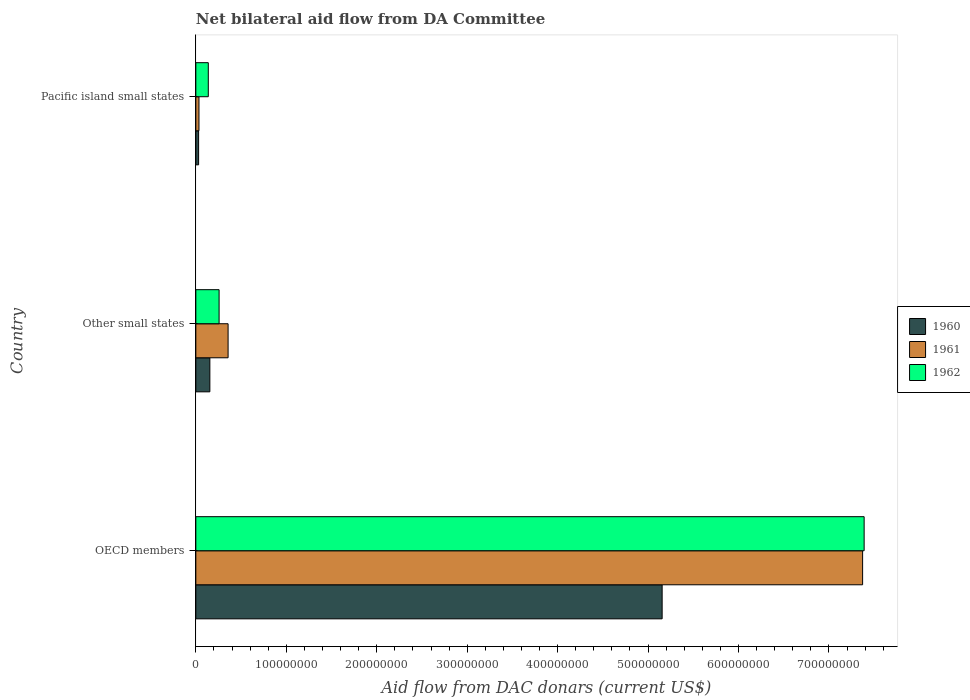How many groups of bars are there?
Make the answer very short. 3. Are the number of bars per tick equal to the number of legend labels?
Your answer should be very brief. Yes. Are the number of bars on each tick of the Y-axis equal?
Make the answer very short. Yes. What is the label of the 2nd group of bars from the top?
Your response must be concise. Other small states. In how many cases, is the number of bars for a given country not equal to the number of legend labels?
Your answer should be very brief. 0. What is the aid flow in in 1962 in OECD members?
Ensure brevity in your answer.  7.39e+08. Across all countries, what is the maximum aid flow in in 1962?
Give a very brief answer. 7.39e+08. Across all countries, what is the minimum aid flow in in 1962?
Your response must be concise. 1.38e+07. In which country was the aid flow in in 1960 maximum?
Provide a succinct answer. OECD members. In which country was the aid flow in in 1961 minimum?
Keep it short and to the point. Pacific island small states. What is the total aid flow in in 1961 in the graph?
Provide a succinct answer. 7.76e+08. What is the difference between the aid flow in in 1962 in OECD members and that in Other small states?
Keep it short and to the point. 7.13e+08. What is the difference between the aid flow in in 1960 in Pacific island small states and the aid flow in in 1962 in OECD members?
Give a very brief answer. -7.36e+08. What is the average aid flow in in 1961 per country?
Provide a short and direct response. 2.59e+08. What is the difference between the aid flow in in 1960 and aid flow in in 1961 in Pacific island small states?
Provide a succinct answer. -3.90e+05. What is the ratio of the aid flow in in 1962 in OECD members to that in Pacific island small states?
Offer a terse response. 53.62. Is the aid flow in in 1960 in OECD members less than that in Other small states?
Offer a very short reply. No. What is the difference between the highest and the second highest aid flow in in 1960?
Ensure brevity in your answer.  5.00e+08. What is the difference between the highest and the lowest aid flow in in 1962?
Offer a terse response. 7.25e+08. Is the sum of the aid flow in in 1960 in OECD members and Pacific island small states greater than the maximum aid flow in in 1961 across all countries?
Provide a succinct answer. No. What does the 3rd bar from the top in OECD members represents?
Your response must be concise. 1960. What does the 3rd bar from the bottom in Pacific island small states represents?
Offer a very short reply. 1962. Is it the case that in every country, the sum of the aid flow in in 1961 and aid flow in in 1960 is greater than the aid flow in in 1962?
Provide a short and direct response. No. How many countries are there in the graph?
Make the answer very short. 3. What is the difference between two consecutive major ticks on the X-axis?
Make the answer very short. 1.00e+08. Are the values on the major ticks of X-axis written in scientific E-notation?
Make the answer very short. No. Does the graph contain grids?
Give a very brief answer. No. Where does the legend appear in the graph?
Make the answer very short. Center right. How many legend labels are there?
Your response must be concise. 3. What is the title of the graph?
Offer a very short reply. Net bilateral aid flow from DA Committee. Does "1984" appear as one of the legend labels in the graph?
Offer a very short reply. No. What is the label or title of the X-axis?
Give a very brief answer. Aid flow from DAC donars (current US$). What is the Aid flow from DAC donars (current US$) in 1960 in OECD members?
Your answer should be very brief. 5.16e+08. What is the Aid flow from DAC donars (current US$) of 1961 in OECD members?
Offer a very short reply. 7.37e+08. What is the Aid flow from DAC donars (current US$) of 1962 in OECD members?
Make the answer very short. 7.39e+08. What is the Aid flow from DAC donars (current US$) of 1960 in Other small states?
Your answer should be very brief. 1.55e+07. What is the Aid flow from DAC donars (current US$) in 1961 in Other small states?
Make the answer very short. 3.57e+07. What is the Aid flow from DAC donars (current US$) in 1962 in Other small states?
Ensure brevity in your answer.  2.57e+07. What is the Aid flow from DAC donars (current US$) of 1960 in Pacific island small states?
Offer a very short reply. 3.08e+06. What is the Aid flow from DAC donars (current US$) in 1961 in Pacific island small states?
Provide a succinct answer. 3.47e+06. What is the Aid flow from DAC donars (current US$) in 1962 in Pacific island small states?
Give a very brief answer. 1.38e+07. Across all countries, what is the maximum Aid flow from DAC donars (current US$) of 1960?
Your answer should be compact. 5.16e+08. Across all countries, what is the maximum Aid flow from DAC donars (current US$) of 1961?
Offer a very short reply. 7.37e+08. Across all countries, what is the maximum Aid flow from DAC donars (current US$) in 1962?
Your answer should be very brief. 7.39e+08. Across all countries, what is the minimum Aid flow from DAC donars (current US$) in 1960?
Keep it short and to the point. 3.08e+06. Across all countries, what is the minimum Aid flow from DAC donars (current US$) of 1961?
Provide a succinct answer. 3.47e+06. Across all countries, what is the minimum Aid flow from DAC donars (current US$) of 1962?
Your answer should be compact. 1.38e+07. What is the total Aid flow from DAC donars (current US$) in 1960 in the graph?
Give a very brief answer. 5.34e+08. What is the total Aid flow from DAC donars (current US$) of 1961 in the graph?
Your answer should be very brief. 7.76e+08. What is the total Aid flow from DAC donars (current US$) in 1962 in the graph?
Keep it short and to the point. 7.78e+08. What is the difference between the Aid flow from DAC donars (current US$) of 1960 in OECD members and that in Other small states?
Your answer should be very brief. 5.00e+08. What is the difference between the Aid flow from DAC donars (current US$) of 1961 in OECD members and that in Other small states?
Provide a short and direct response. 7.02e+08. What is the difference between the Aid flow from DAC donars (current US$) in 1962 in OECD members and that in Other small states?
Your answer should be compact. 7.13e+08. What is the difference between the Aid flow from DAC donars (current US$) in 1960 in OECD members and that in Pacific island small states?
Your response must be concise. 5.12e+08. What is the difference between the Aid flow from DAC donars (current US$) in 1961 in OECD members and that in Pacific island small states?
Provide a succinct answer. 7.34e+08. What is the difference between the Aid flow from DAC donars (current US$) in 1962 in OECD members and that in Pacific island small states?
Your answer should be compact. 7.25e+08. What is the difference between the Aid flow from DAC donars (current US$) in 1960 in Other small states and that in Pacific island small states?
Ensure brevity in your answer.  1.24e+07. What is the difference between the Aid flow from DAC donars (current US$) in 1961 in Other small states and that in Pacific island small states?
Ensure brevity in your answer.  3.22e+07. What is the difference between the Aid flow from DAC donars (current US$) in 1962 in Other small states and that in Pacific island small states?
Keep it short and to the point. 1.19e+07. What is the difference between the Aid flow from DAC donars (current US$) in 1960 in OECD members and the Aid flow from DAC donars (current US$) in 1961 in Other small states?
Provide a succinct answer. 4.80e+08. What is the difference between the Aid flow from DAC donars (current US$) in 1960 in OECD members and the Aid flow from DAC donars (current US$) in 1962 in Other small states?
Your answer should be compact. 4.90e+08. What is the difference between the Aid flow from DAC donars (current US$) in 1961 in OECD members and the Aid flow from DAC donars (current US$) in 1962 in Other small states?
Offer a terse response. 7.11e+08. What is the difference between the Aid flow from DAC donars (current US$) in 1960 in OECD members and the Aid flow from DAC donars (current US$) in 1961 in Pacific island small states?
Provide a succinct answer. 5.12e+08. What is the difference between the Aid flow from DAC donars (current US$) in 1960 in OECD members and the Aid flow from DAC donars (current US$) in 1962 in Pacific island small states?
Offer a very short reply. 5.02e+08. What is the difference between the Aid flow from DAC donars (current US$) of 1961 in OECD members and the Aid flow from DAC donars (current US$) of 1962 in Pacific island small states?
Offer a very short reply. 7.23e+08. What is the difference between the Aid flow from DAC donars (current US$) in 1960 in Other small states and the Aid flow from DAC donars (current US$) in 1961 in Pacific island small states?
Make the answer very short. 1.20e+07. What is the difference between the Aid flow from DAC donars (current US$) of 1960 in Other small states and the Aid flow from DAC donars (current US$) of 1962 in Pacific island small states?
Your response must be concise. 1.74e+06. What is the difference between the Aid flow from DAC donars (current US$) of 1961 in Other small states and the Aid flow from DAC donars (current US$) of 1962 in Pacific island small states?
Ensure brevity in your answer.  2.19e+07. What is the average Aid flow from DAC donars (current US$) of 1960 per country?
Keep it short and to the point. 1.78e+08. What is the average Aid flow from DAC donars (current US$) in 1961 per country?
Your answer should be compact. 2.59e+08. What is the average Aid flow from DAC donars (current US$) of 1962 per country?
Provide a short and direct response. 2.59e+08. What is the difference between the Aid flow from DAC donars (current US$) of 1960 and Aid flow from DAC donars (current US$) of 1961 in OECD members?
Your response must be concise. -2.22e+08. What is the difference between the Aid flow from DAC donars (current US$) of 1960 and Aid flow from DAC donars (current US$) of 1962 in OECD members?
Your answer should be compact. -2.23e+08. What is the difference between the Aid flow from DAC donars (current US$) in 1961 and Aid flow from DAC donars (current US$) in 1962 in OECD members?
Provide a succinct answer. -1.69e+06. What is the difference between the Aid flow from DAC donars (current US$) in 1960 and Aid flow from DAC donars (current US$) in 1961 in Other small states?
Ensure brevity in your answer.  -2.02e+07. What is the difference between the Aid flow from DAC donars (current US$) in 1960 and Aid flow from DAC donars (current US$) in 1962 in Other small states?
Make the answer very short. -1.02e+07. What is the difference between the Aid flow from DAC donars (current US$) in 1961 and Aid flow from DAC donars (current US$) in 1962 in Other small states?
Keep it short and to the point. 9.95e+06. What is the difference between the Aid flow from DAC donars (current US$) in 1960 and Aid flow from DAC donars (current US$) in 1961 in Pacific island small states?
Your response must be concise. -3.90e+05. What is the difference between the Aid flow from DAC donars (current US$) of 1960 and Aid flow from DAC donars (current US$) of 1962 in Pacific island small states?
Your response must be concise. -1.07e+07. What is the difference between the Aid flow from DAC donars (current US$) in 1961 and Aid flow from DAC donars (current US$) in 1962 in Pacific island small states?
Keep it short and to the point. -1.03e+07. What is the ratio of the Aid flow from DAC donars (current US$) in 1960 in OECD members to that in Other small states?
Keep it short and to the point. 33.22. What is the ratio of the Aid flow from DAC donars (current US$) in 1961 in OECD members to that in Other small states?
Provide a short and direct response. 20.67. What is the ratio of the Aid flow from DAC donars (current US$) of 1962 in OECD members to that in Other small states?
Your answer should be compact. 28.73. What is the ratio of the Aid flow from DAC donars (current US$) of 1960 in OECD members to that in Pacific island small states?
Provide a succinct answer. 167.39. What is the ratio of the Aid flow from DAC donars (current US$) in 1961 in OECD members to that in Pacific island small states?
Ensure brevity in your answer.  212.45. What is the ratio of the Aid flow from DAC donars (current US$) of 1962 in OECD members to that in Pacific island small states?
Ensure brevity in your answer.  53.62. What is the ratio of the Aid flow from DAC donars (current US$) in 1960 in Other small states to that in Pacific island small states?
Provide a succinct answer. 5.04. What is the ratio of the Aid flow from DAC donars (current US$) of 1961 in Other small states to that in Pacific island small states?
Give a very brief answer. 10.28. What is the ratio of the Aid flow from DAC donars (current US$) of 1962 in Other small states to that in Pacific island small states?
Offer a very short reply. 1.87. What is the difference between the highest and the second highest Aid flow from DAC donars (current US$) in 1960?
Give a very brief answer. 5.00e+08. What is the difference between the highest and the second highest Aid flow from DAC donars (current US$) in 1961?
Make the answer very short. 7.02e+08. What is the difference between the highest and the second highest Aid flow from DAC donars (current US$) of 1962?
Your response must be concise. 7.13e+08. What is the difference between the highest and the lowest Aid flow from DAC donars (current US$) of 1960?
Your response must be concise. 5.12e+08. What is the difference between the highest and the lowest Aid flow from DAC donars (current US$) in 1961?
Provide a short and direct response. 7.34e+08. What is the difference between the highest and the lowest Aid flow from DAC donars (current US$) in 1962?
Provide a short and direct response. 7.25e+08. 